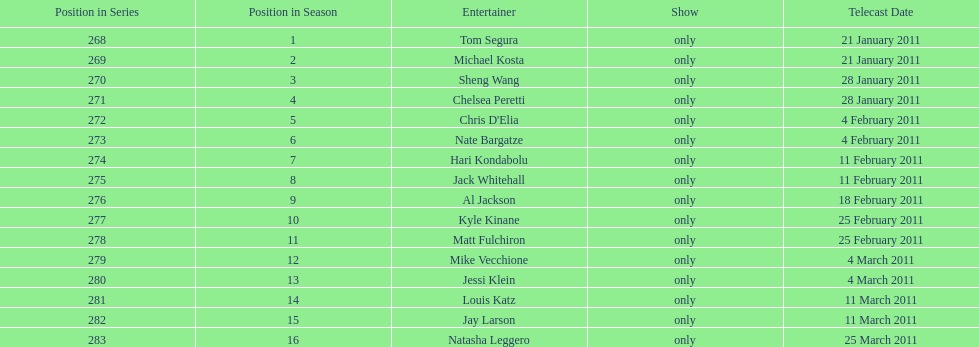What were the total number of air dates in february? 7. 